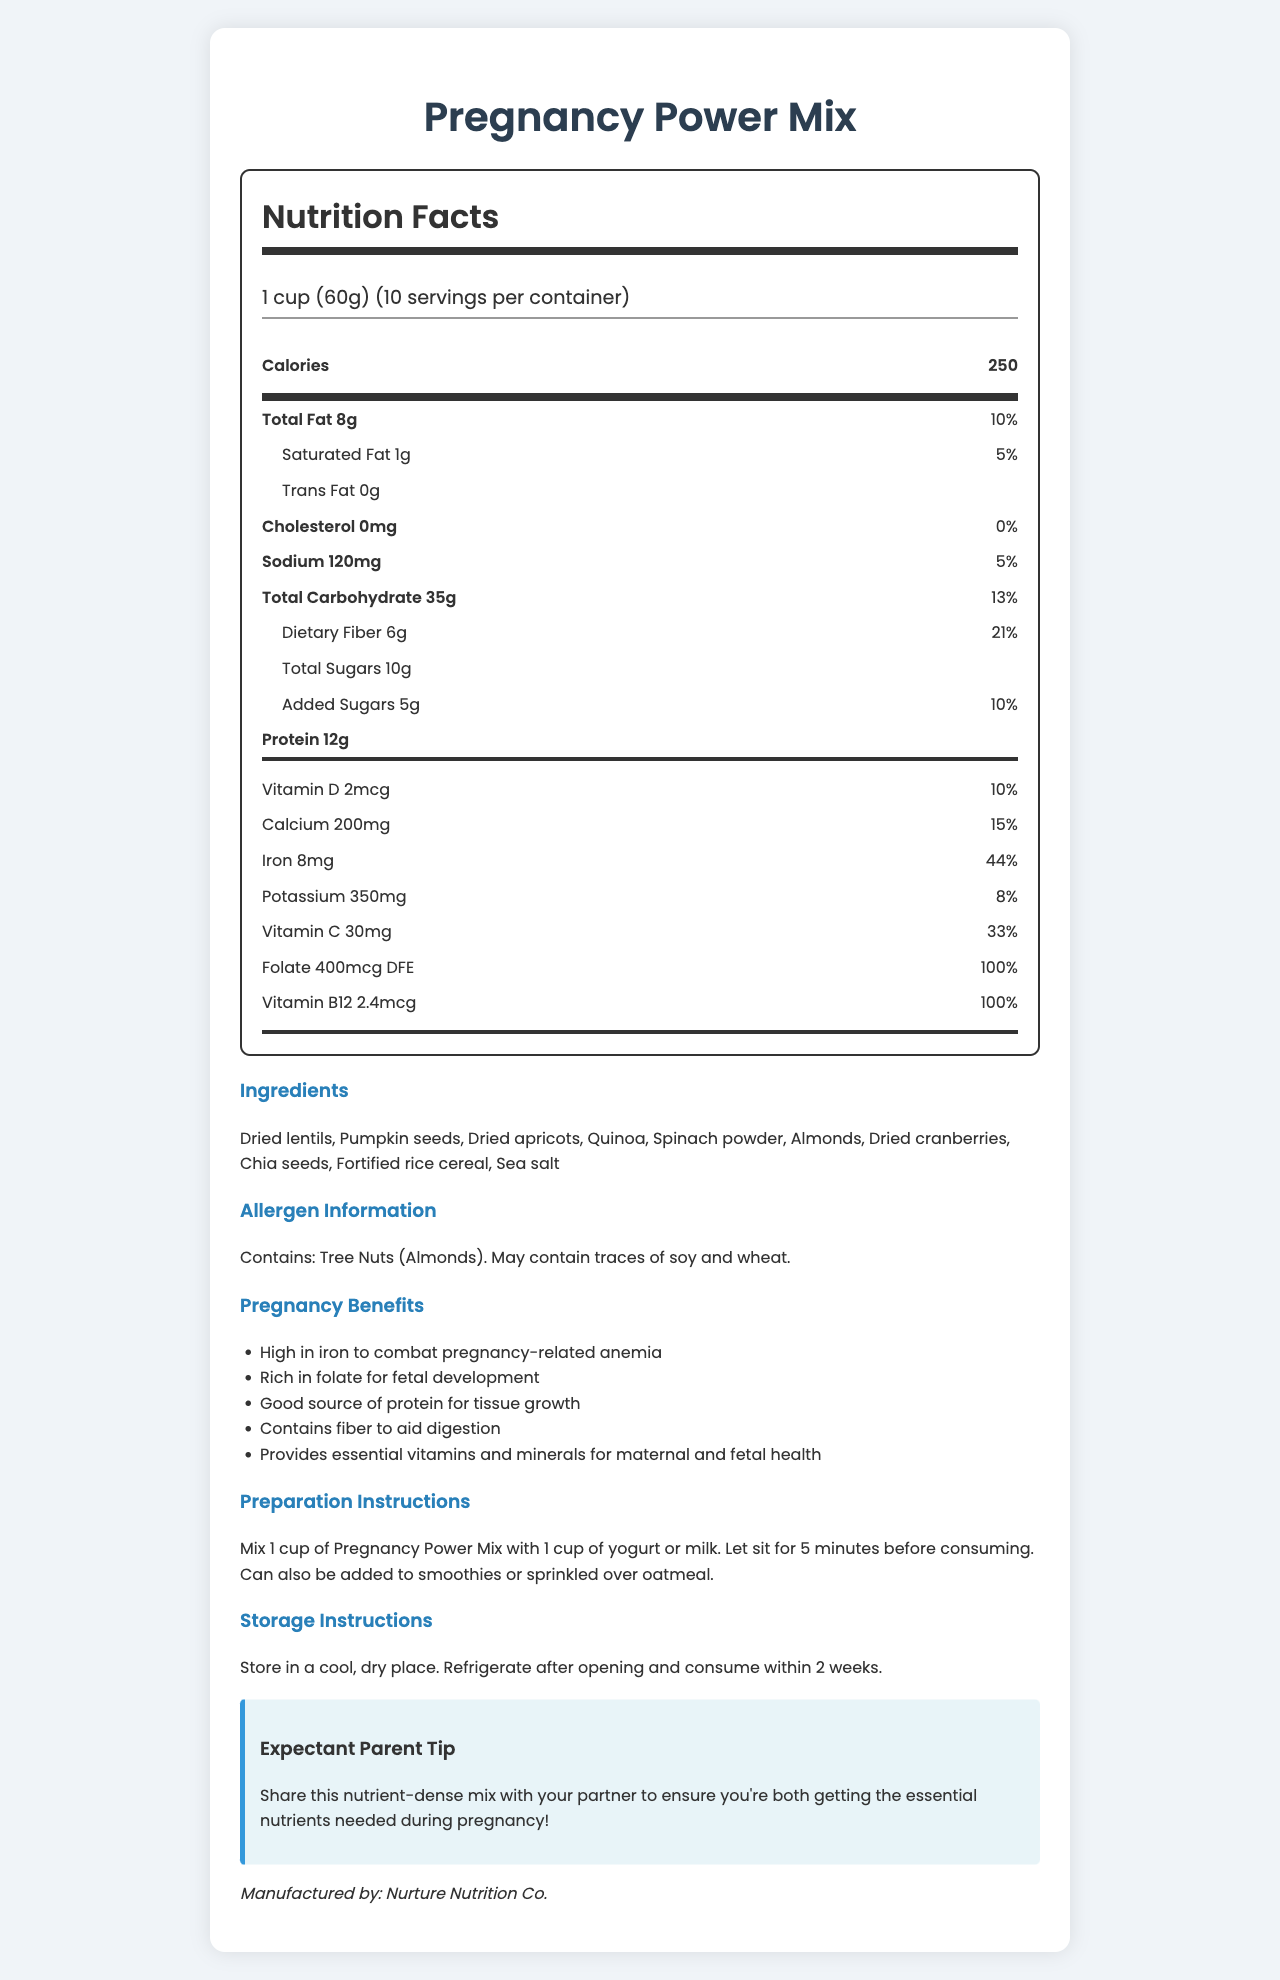who manufactures the Pregnancy Power Mix? The document states this at the bottom with "Manufactured by: Nurture Nutrition Co."
Answer: Nurture Nutrition Co. how much iron does one serving of Pregnancy Power Mix provide? The nutrition label shows that one serving includes 8mg of iron.
Answer: 8mg what is the daily value percentage for folate in Pregnancy Power Mix? The vitamin section of the nutrition label indicates that one serving provides 100% of the daily value for folate.
Answer: 100% does the Pregnancy Power Mix contain any allergens? The allergen information section indicates that the mix contains tree nuts (almonds) and may contain traces of soy and wheat.
Answer: Yes how much dietary fiber is in one serving? According to the nutrition label, one serving contains 6g of dietary fiber.
Answer: 6g what are the preparation instructions for this product? The preparation instructions detail these steps.
Answer: Mix 1 cup of Pregnancy Power Mix with 1 cup of yogurt or milk. Let sit for 5 minutes before consuming. Can also be added to smoothies or sprinkled over oatmeal. how many servings are in one container? The serving information indicates that there are 10 servings per container.
Answer: 10 is there any Vitamin D in this product? The nutrition label shows that one serving contains 2mcg of Vitamin D.
Answer: Yes what is the main idea of this document? This summary was derived from the comprehensive details provided in different sections of the document.
Answer: The document provides detailed information about the Nutrition Facts, ingredients, pregnancy benefits, preparation, storage instructions, and allergen information for "Pregnancy Power Mix". what percentage of daily calcium does this product provide? A. 10% B. 15% C. 20% D. 25% The vitamin section of the nutrition label indicates that one serving provides 15% of the daily value for calcium.
Answer: B. 15% which ingredient is found in the Pregnancy Power Mix? A. Walnuts B. Spinach powder C. Blueberries D. Chocolate chips Spinach powder is listed among the ingredients, while the other options are not.
Answer: B. Spinach powder is this product suitable for individuals with tree nut allergies? The allergen information indicates that the product contains tree nuts (almonds).
Answer: No which nutrient in Pregnancy Power Mix helps combat pregnancy-related anemia? The pregnancy benefits section mentions that the product is high in iron, which helps combat pregnancy-related anemia.
Answer: Iron what is the manufacturer of Pregnancy Power Mix's street address? The document does not provide any specific address information for the manufacturer.
Answer: Cannot be determined how much protein does one serving of Pregnancy Power Mix provide? The nutrition label shows that one serving includes 12g of protein.
Answer: 12g which nutrient in this product is crucial for fetal development? The pregnancy benefits section states that the product is rich in folate, which is essential for fetal development.
Answer: Folate 